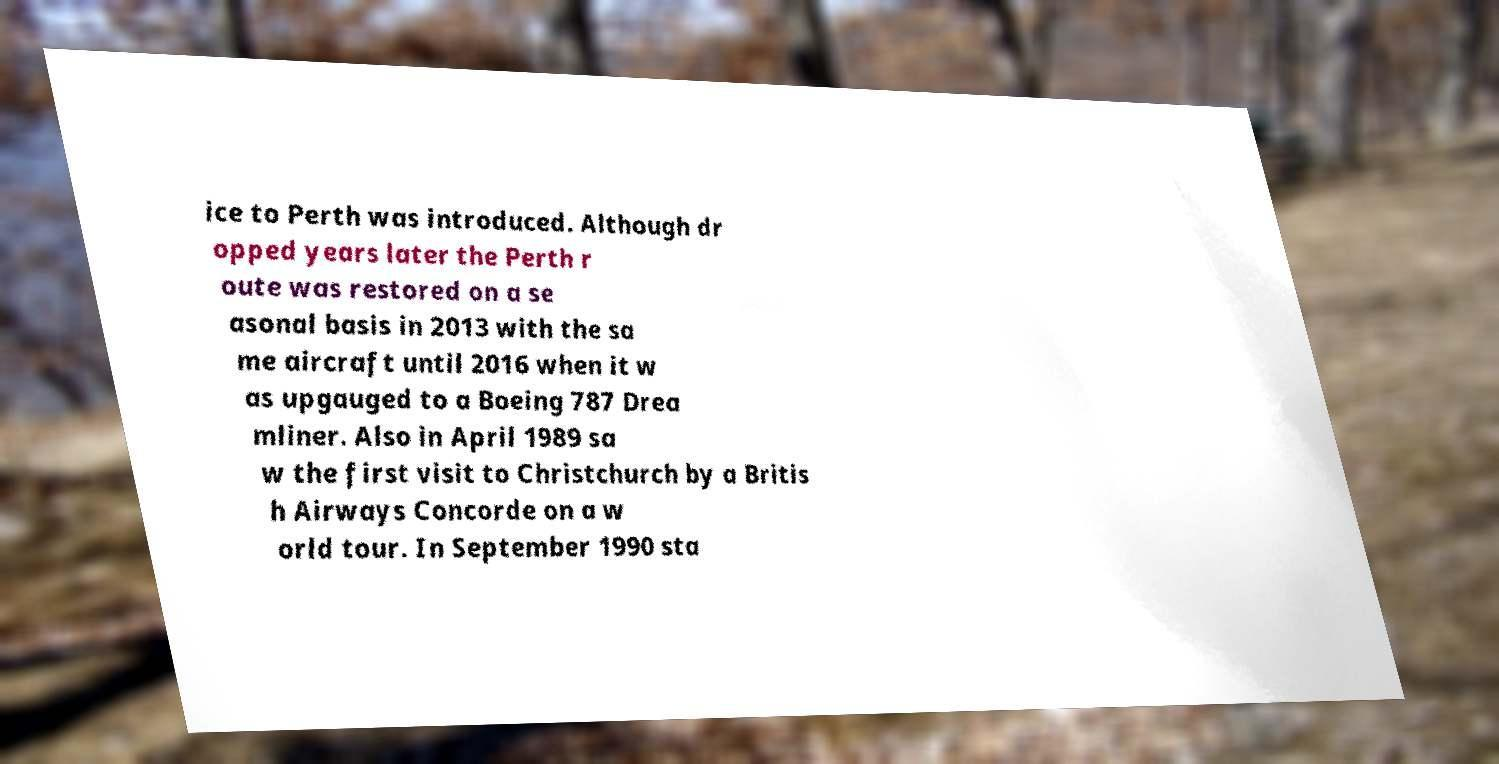Please read and relay the text visible in this image. What does it say? ice to Perth was introduced. Although dr opped years later the Perth r oute was restored on a se asonal basis in 2013 with the sa me aircraft until 2016 when it w as upgauged to a Boeing 787 Drea mliner. Also in April 1989 sa w the first visit to Christchurch by a Britis h Airways Concorde on a w orld tour. In September 1990 sta 